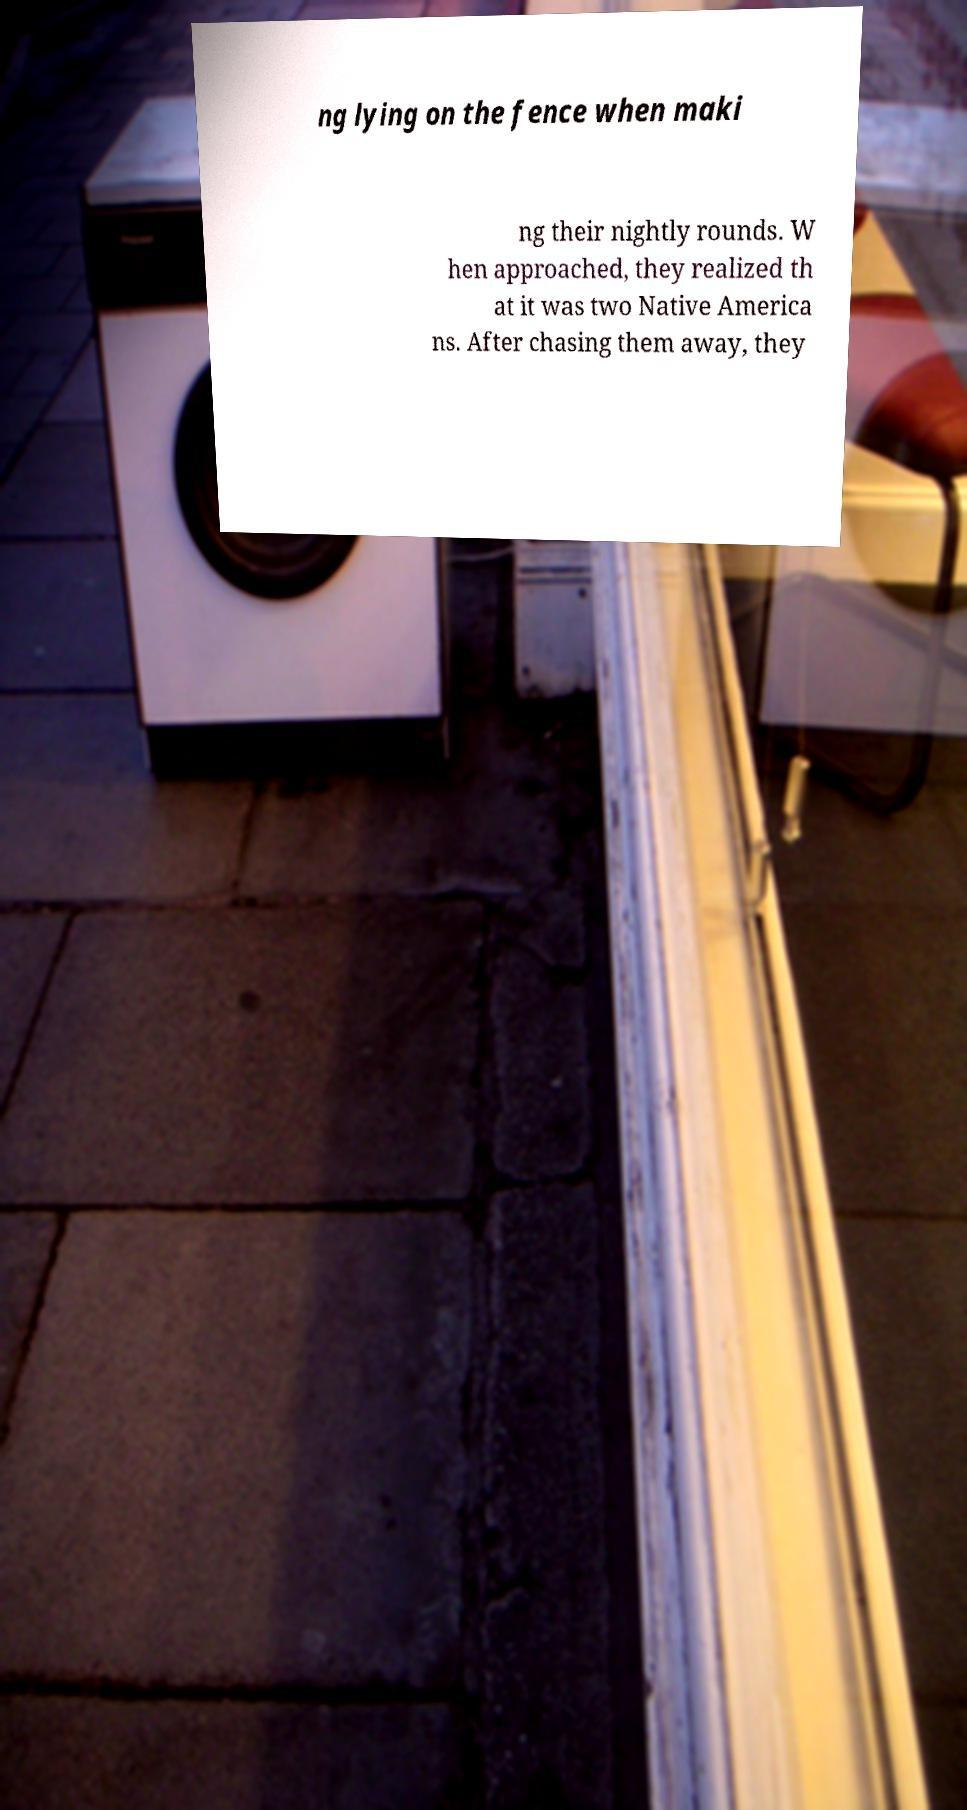Could you assist in decoding the text presented in this image and type it out clearly? ng lying on the fence when maki ng their nightly rounds. W hen approached, they realized th at it was two Native America ns. After chasing them away, they 